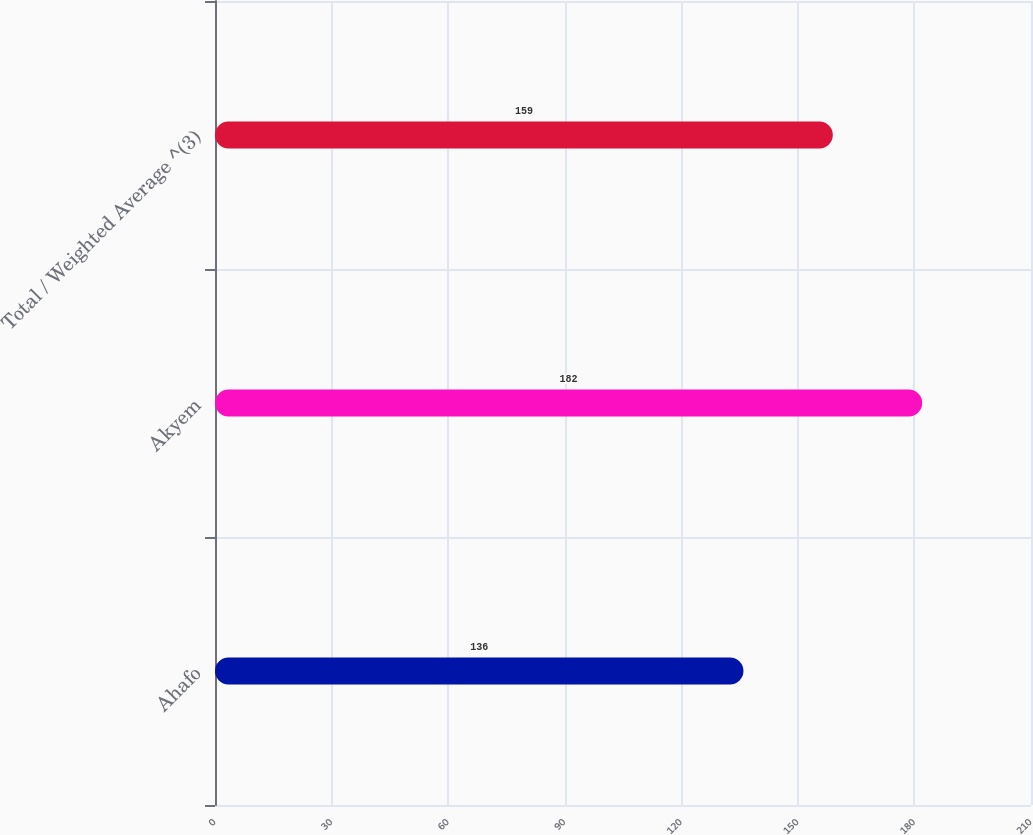Convert chart. <chart><loc_0><loc_0><loc_500><loc_500><bar_chart><fcel>Ahafo<fcel>Akyem<fcel>Total / Weighted Average ^(3)<nl><fcel>136<fcel>182<fcel>159<nl></chart> 